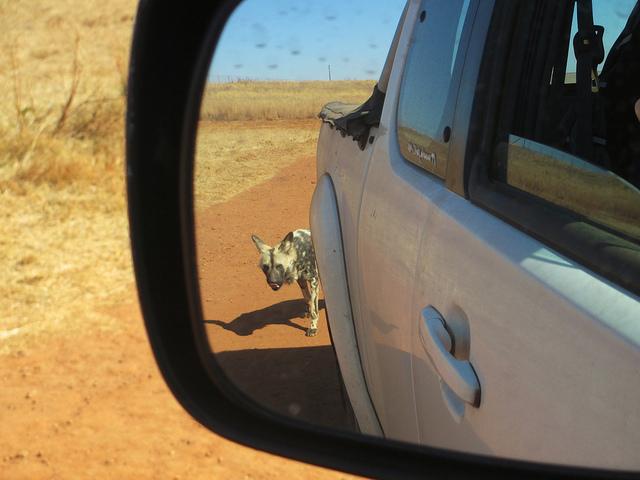What is the dog doing?
Give a very brief answer. Walking. Where is the dog seen?
Write a very short answer. Mirror. Is this a coyote?
Quick response, please. Yes. What color is the vehicle?
Keep it brief. White. What is the dog riding in?
Quick response, please. Nothing. 